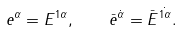Convert formula to latex. <formula><loc_0><loc_0><loc_500><loc_500>e ^ { \alpha } = E ^ { 1 \alpha } , \quad \bar { e } ^ { \dot { \alpha } } = \bar { E } ^ { \dot { 1 \alpha } } .</formula> 